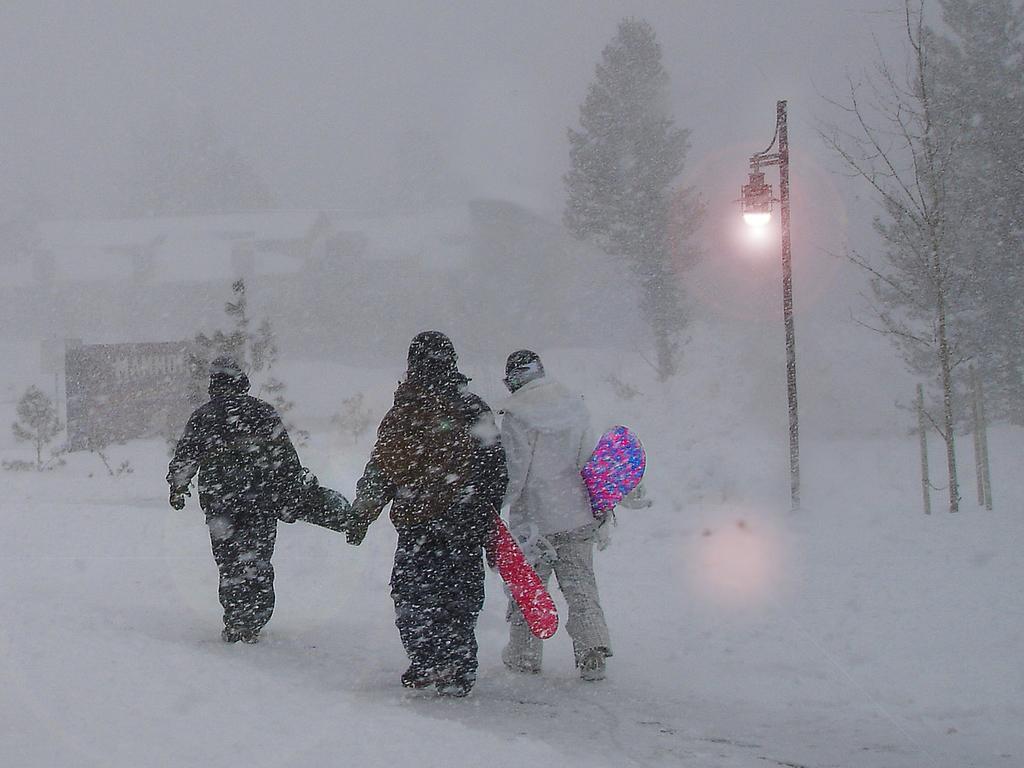Describe this image in one or two sentences. In the center of the image we can see three persons are standing and they are in different costumes and they are holding some objects. And we can see trees, one light pole and snow. In the background, we can see it is blurred. 